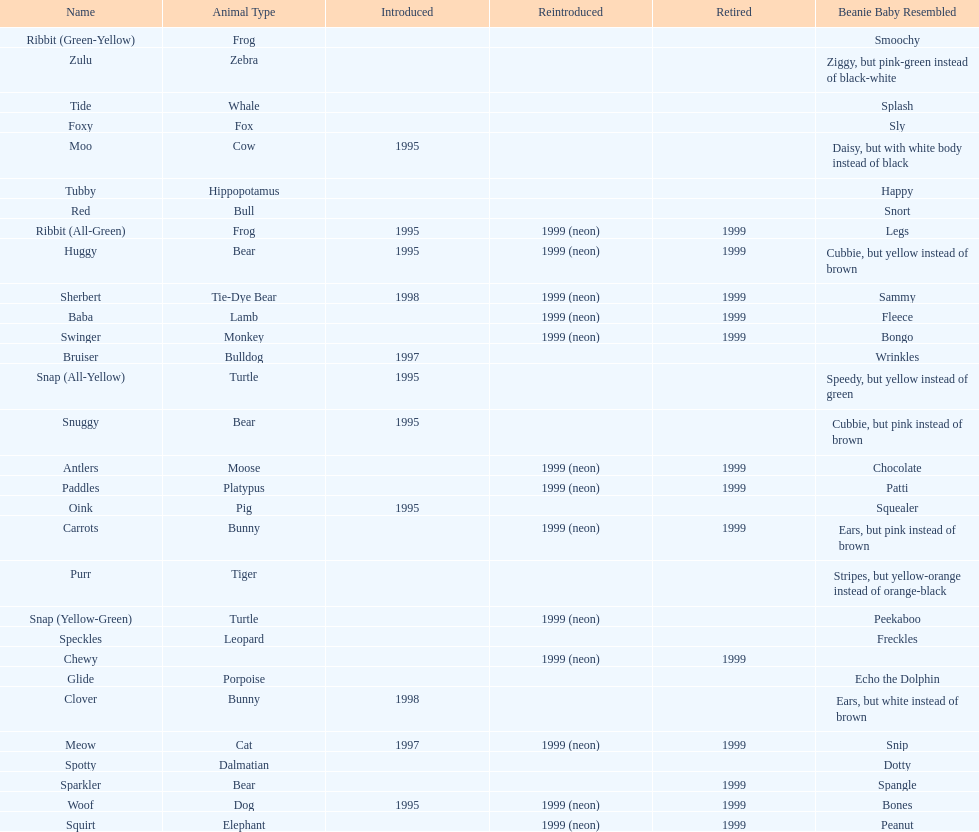What is the number of frog pillow pals? 2. 